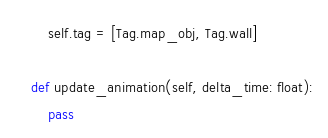Convert code to text. <code><loc_0><loc_0><loc_500><loc_500><_Python_>        self.tag = [Tag.map_obj, Tag.wall]

    def update_animation(self, delta_time: float):
        pass
</code> 